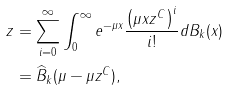<formula> <loc_0><loc_0><loc_500><loc_500>z & = \sum _ { i = 0 } ^ { \infty } \int _ { 0 } ^ { \infty } e ^ { - \mu x } \frac { \left ( \mu x z ^ { C } \right ) ^ { i } } { i ! } d B _ { k } ( x ) \\ & = \widehat { B } _ { k } ( \mu - \mu z ^ { C } ) ,</formula> 